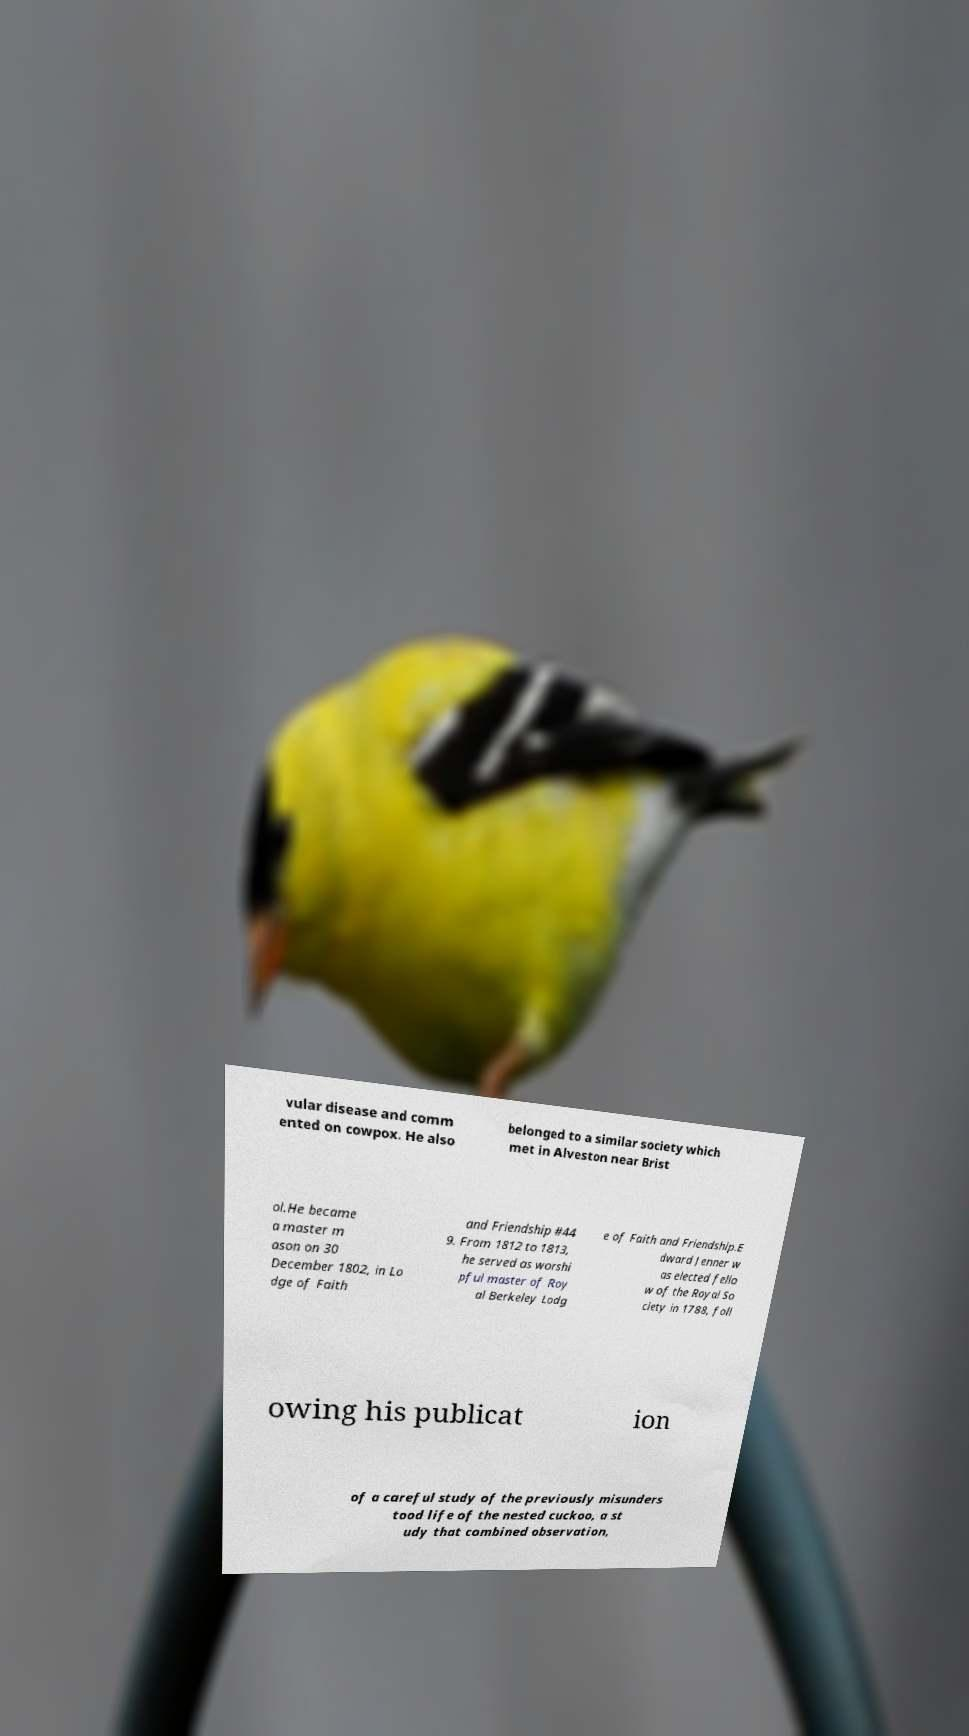What messages or text are displayed in this image? I need them in a readable, typed format. vular disease and comm ented on cowpox. He also belonged to a similar society which met in Alveston near Brist ol.He became a master m ason on 30 December 1802, in Lo dge of Faith and Friendship #44 9. From 1812 to 1813, he served as worshi pful master of Roy al Berkeley Lodg e of Faith and Friendship.E dward Jenner w as elected fello w of the Royal So ciety in 1788, foll owing his publicat ion of a careful study of the previously misunders tood life of the nested cuckoo, a st udy that combined observation, 